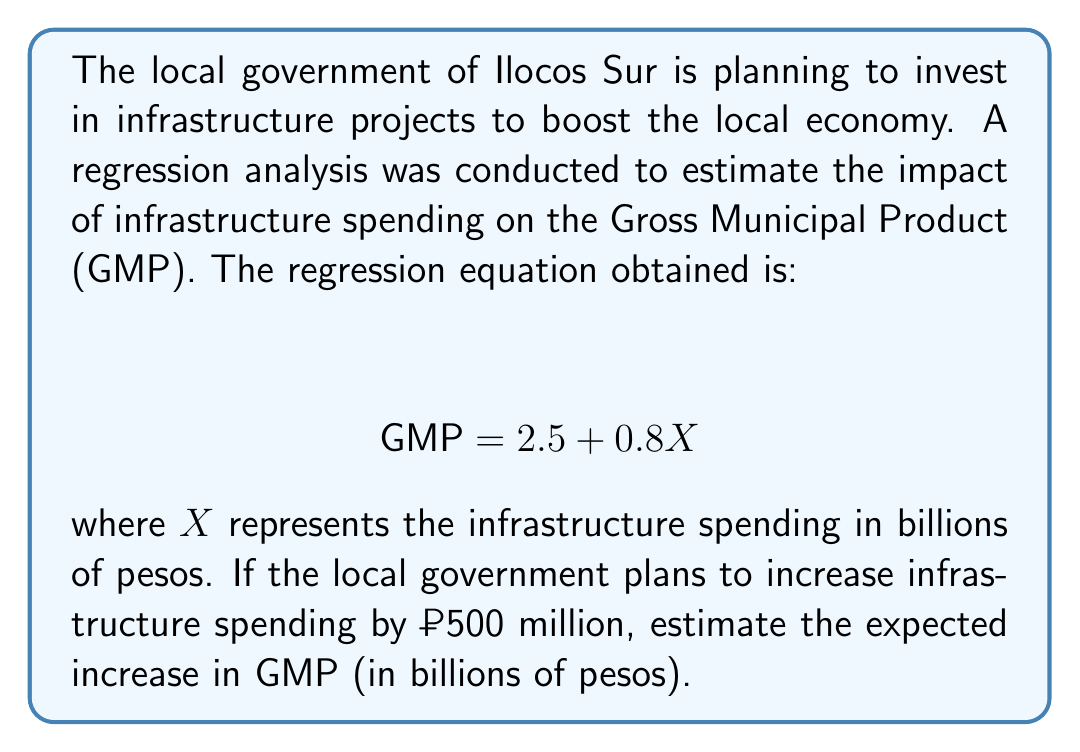Teach me how to tackle this problem. To solve this problem, we need to follow these steps:

1. Understand the regression equation:
   $$ \text{GMP} = 2.5 + 0.8X $$
   Where GMP is in billions of pesos and X is the infrastructure spending in billions of pesos.

2. Calculate the change in X:
   The planned increase in infrastructure spending is ₱500 million, which is equivalent to 0.5 billion pesos.
   $$ \Delta X = 0.5 \text{ billion pesos} $$

3. Use the slope of the regression line to calculate the change in GMP:
   The slope of the line is 0.8, which represents the change in GMP for each unit change in X.
   $$ \Delta \text{GMP} = 0.8 \times \Delta X $$
   $$ \Delta \text{GMP} = 0.8 \times 0.5 $$
   $$ \Delta \text{GMP} = 0.4 \text{ billion pesos} $$

Therefore, an increase in infrastructure spending of ₱500 million is estimated to increase the Gross Municipal Product by 0.4 billion pesos.
Answer: $0.4 \text{ billion pesos}$ 